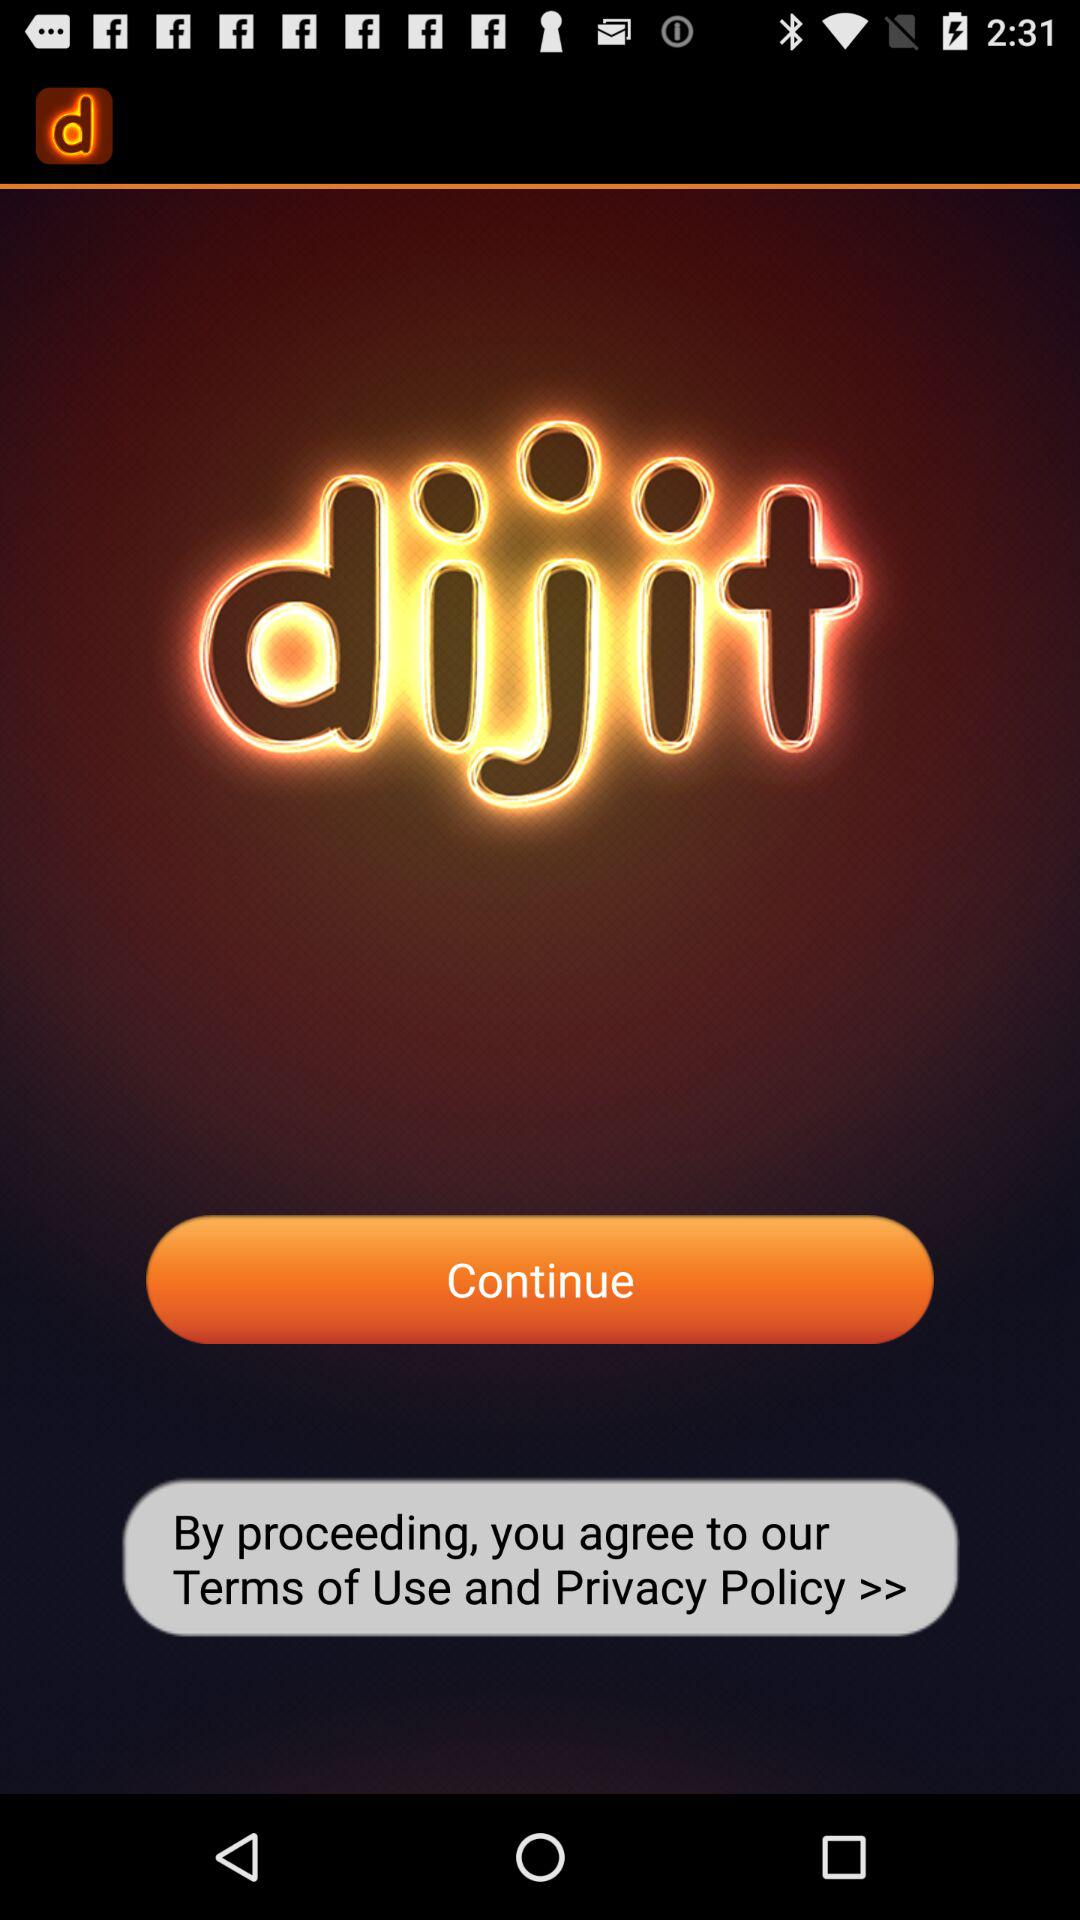What is the application name? The application name is "dijit". 